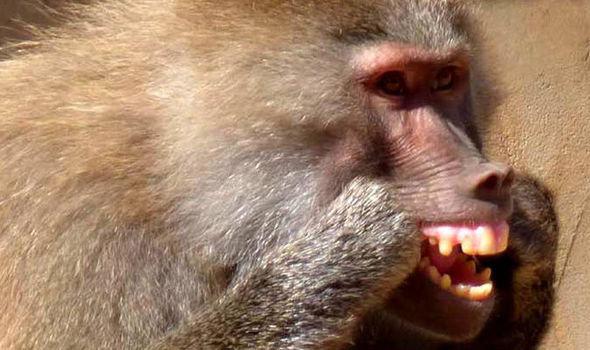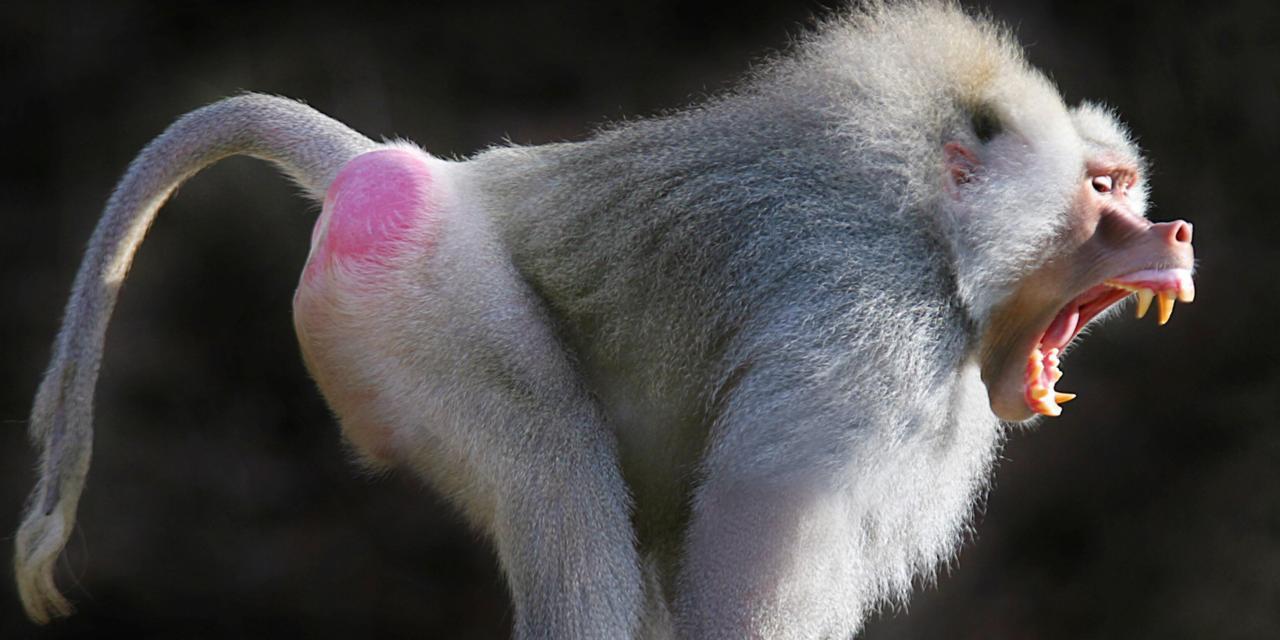The first image is the image on the left, the second image is the image on the right. Given the left and right images, does the statement "Teeth are visible in the baboons in each image." hold true? Answer yes or no. Yes. 